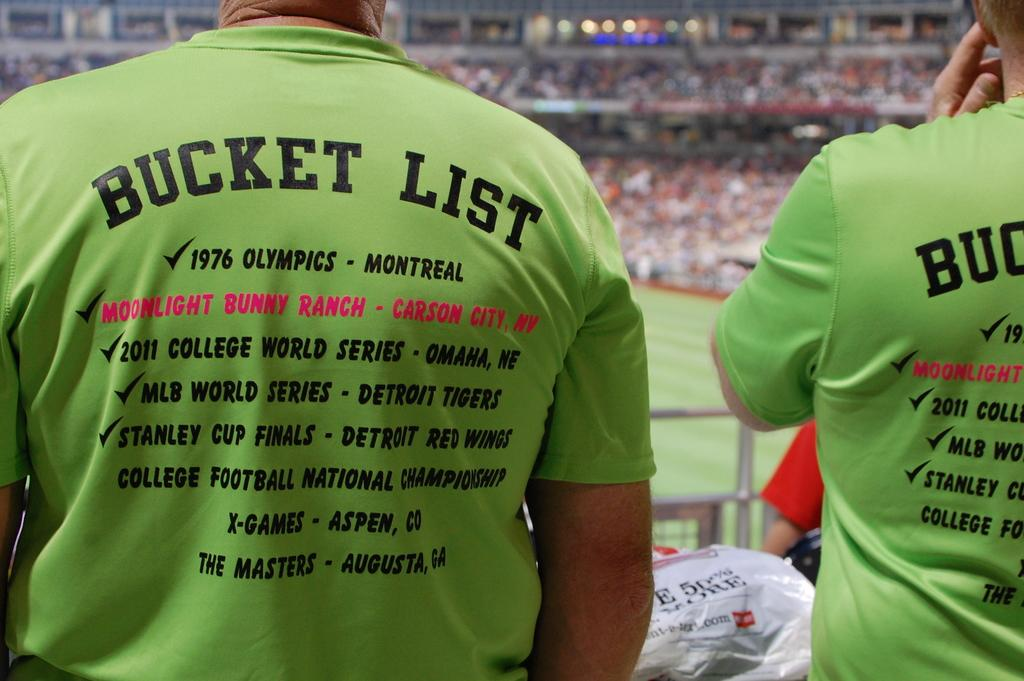Provide a one-sentence caption for the provided image. Two people wearing tee shirts with bucket list on the back. 